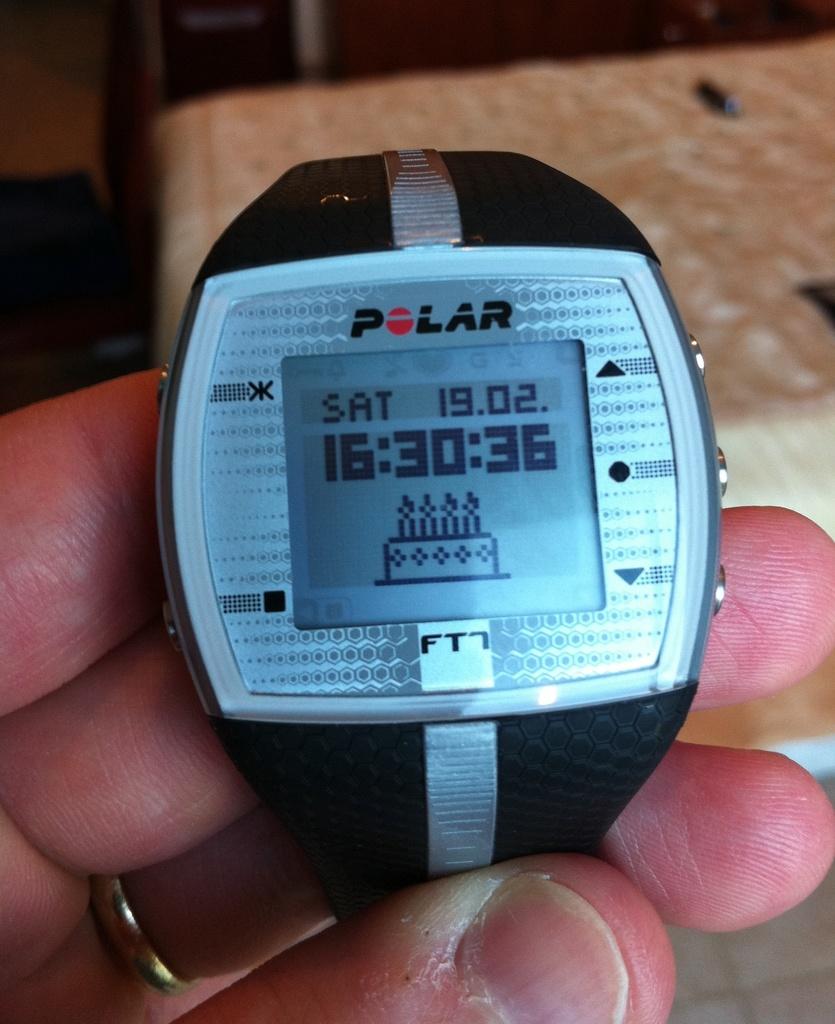Who makes this smart watch?
Offer a very short reply. Polar. What date is shown here?
Your answer should be very brief. 19.02. 